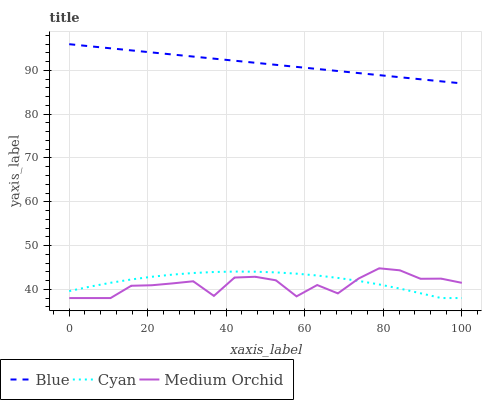Does Cyan have the minimum area under the curve?
Answer yes or no. No. Does Cyan have the maximum area under the curve?
Answer yes or no. No. Is Cyan the smoothest?
Answer yes or no. No. Is Cyan the roughest?
Answer yes or no. No. Does Medium Orchid have the highest value?
Answer yes or no. No. Is Cyan less than Blue?
Answer yes or no. Yes. Is Blue greater than Medium Orchid?
Answer yes or no. Yes. Does Cyan intersect Blue?
Answer yes or no. No. 